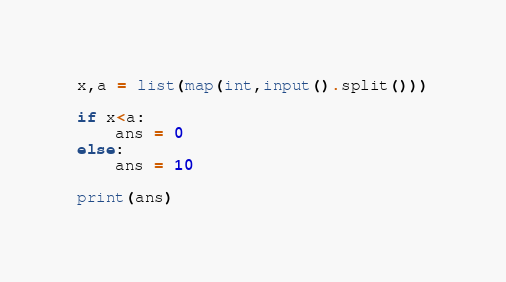<code> <loc_0><loc_0><loc_500><loc_500><_Python_>x,a = list(map(int,input().split()))

if x<a:
    ans = 0
else:
    ans = 10

print(ans)</code> 